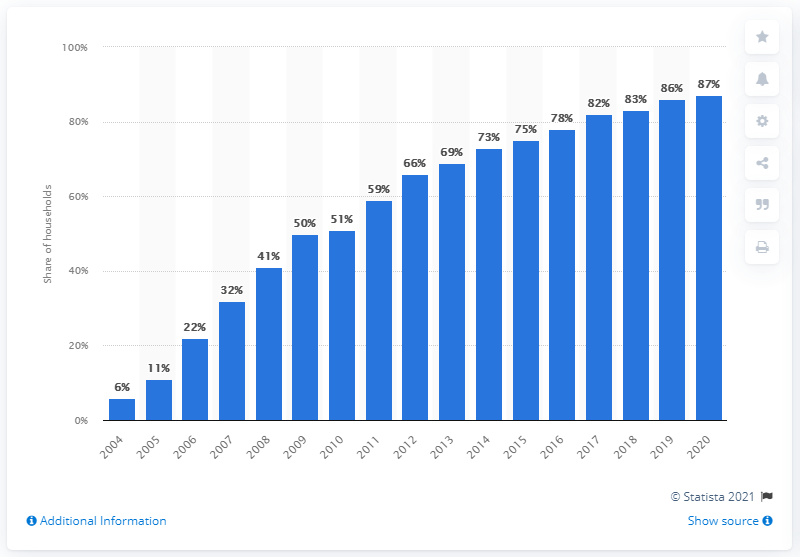List a handful of essential elements in this visual. In 2020, there was a significant increase in broadband internet access in Hungary, with a notable increase of 87%. In 2020, broadband internet access was widely available in households in Hungary, with an overall share of 87%. 